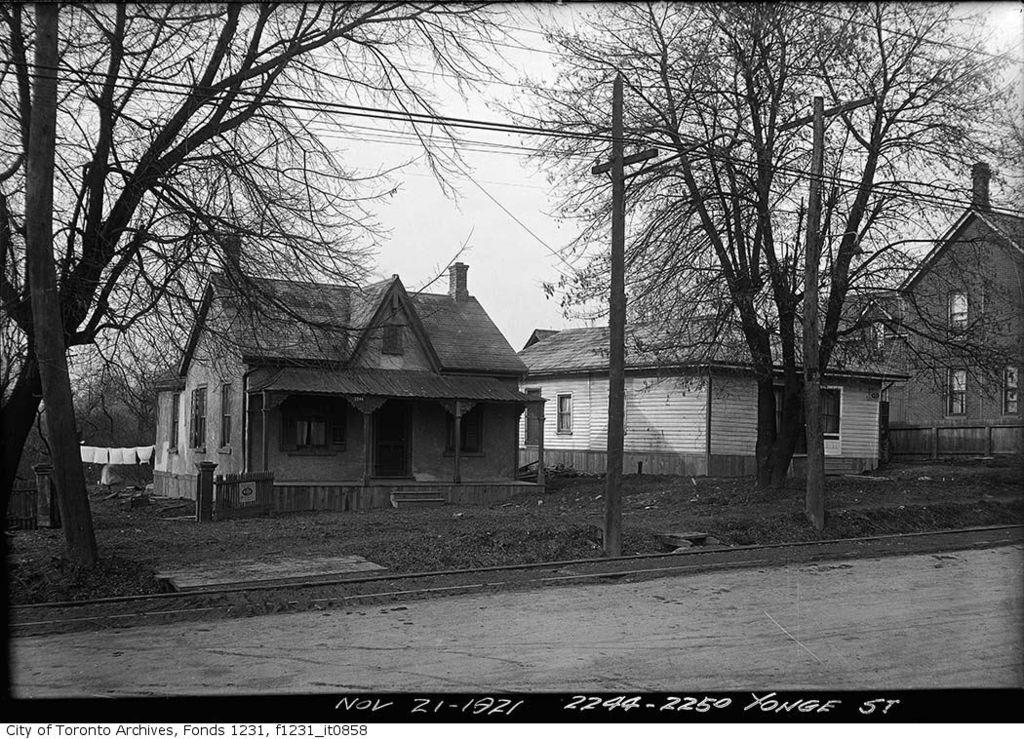What type of structures can be seen in the image? There are houses in the image. What architectural feature is present in the image? There are stairs in the image. What type of barrier is visible in the image? There is a fence in the image. What type of vegetation is present in the image? There are trees in the image. What is visible in the background of the image? The sky is visible in the image. What does the mom say about the trade and slave situation in the image? There is no mention of a mom, trade, or slave situation in the image. The image features houses, stairs, a fence, trees, and the sky. 